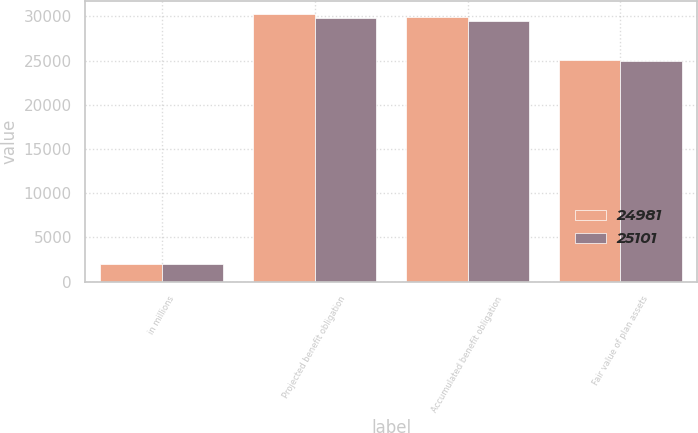<chart> <loc_0><loc_0><loc_500><loc_500><stacked_bar_chart><ecel><fcel>in millions<fcel>Projected benefit obligation<fcel>Accumulated benefit obligation<fcel>Fair value of plan assets<nl><fcel>24981<fcel>2018<fcel>30259<fcel>29961<fcel>25101<nl><fcel>25101<fcel>2017<fcel>29804<fcel>29454<fcel>24981<nl></chart> 